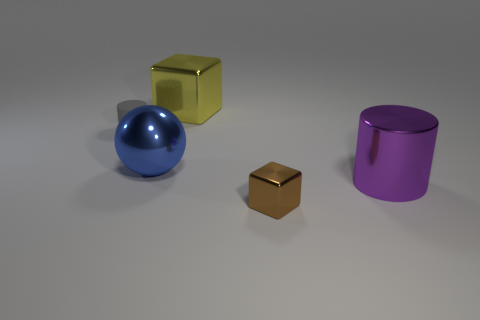There is a metallic object that is right of the brown thing; is it the same size as the brown object?
Ensure brevity in your answer.  No. Does the yellow block have the same material as the cylinder that is in front of the tiny gray rubber cylinder?
Your answer should be compact. Yes. The shiny block left of the small shiny thing is what color?
Offer a very short reply. Yellow. There is a metallic block in front of the matte thing; are there any gray cylinders that are right of it?
Make the answer very short. No. Do the metallic block in front of the rubber cylinder and the small object to the left of the big yellow metal block have the same color?
Your response must be concise. No. How many spheres are to the right of the yellow metallic cube?
Your response must be concise. 0. Is the material of the cylinder left of the blue metallic object the same as the brown object?
Make the answer very short. No. How many yellow cubes are the same material as the big blue ball?
Your answer should be very brief. 1. Is the number of matte cylinders in front of the purple metal cylinder greater than the number of large cyan matte cubes?
Give a very brief answer. No. Is there a big cyan object of the same shape as the tiny gray thing?
Your answer should be very brief. No. 